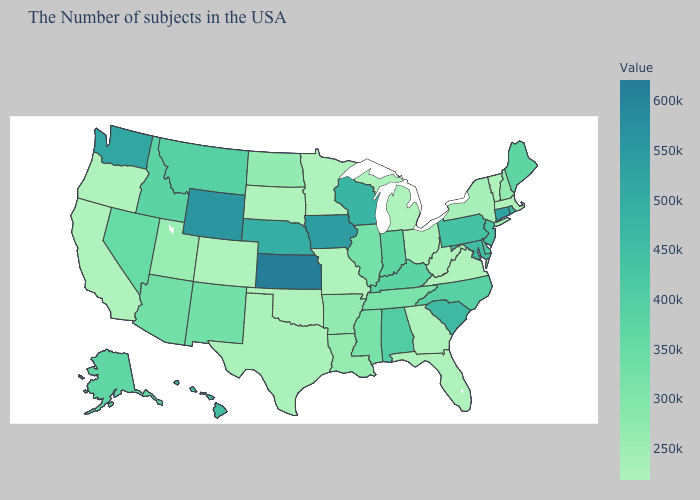Does Wyoming have the highest value in the West?
Quick response, please. Yes. Is the legend a continuous bar?
Short answer required. Yes. Does North Carolina have a higher value than Texas?
Concise answer only. Yes. Is the legend a continuous bar?
Write a very short answer. Yes. Does Massachusetts have the lowest value in the Northeast?
Give a very brief answer. Yes. Among the states that border Nevada , which have the highest value?
Answer briefly. Idaho. 